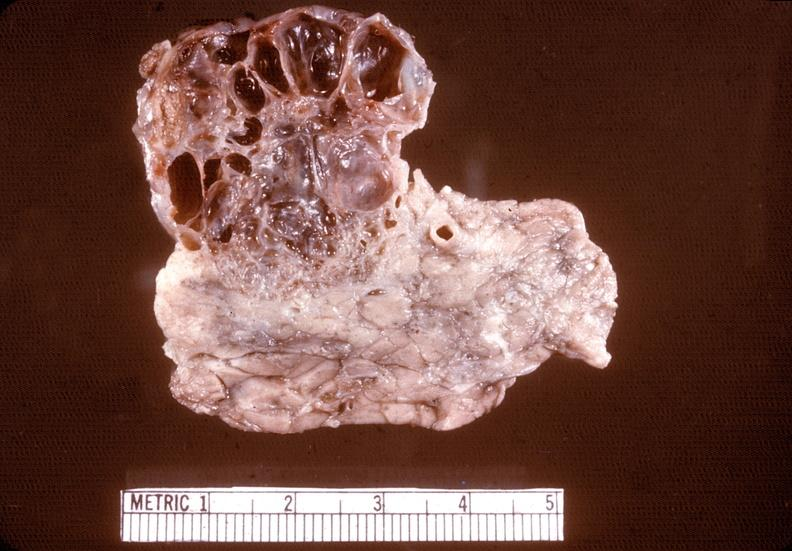what does this image show?
Answer the question using a single word or phrase. Cystadenoma 